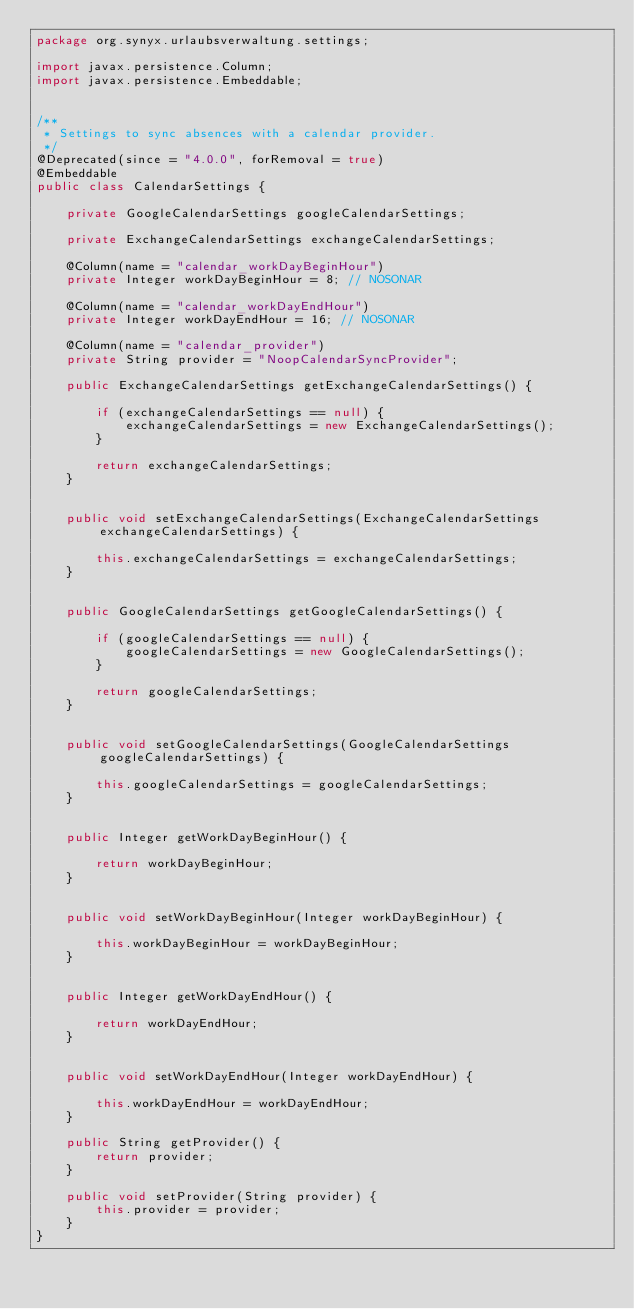Convert code to text. <code><loc_0><loc_0><loc_500><loc_500><_Java_>package org.synyx.urlaubsverwaltung.settings;

import javax.persistence.Column;
import javax.persistence.Embeddable;


/**
 * Settings to sync absences with a calendar provider.
 */
@Deprecated(since = "4.0.0", forRemoval = true)
@Embeddable
public class CalendarSettings {

    private GoogleCalendarSettings googleCalendarSettings;

    private ExchangeCalendarSettings exchangeCalendarSettings;

    @Column(name = "calendar_workDayBeginHour")
    private Integer workDayBeginHour = 8; // NOSONAR

    @Column(name = "calendar_workDayEndHour")
    private Integer workDayEndHour = 16; // NOSONAR

    @Column(name = "calendar_provider")
    private String provider = "NoopCalendarSyncProvider";

    public ExchangeCalendarSettings getExchangeCalendarSettings() {

        if (exchangeCalendarSettings == null) {
            exchangeCalendarSettings = new ExchangeCalendarSettings();
        }

        return exchangeCalendarSettings;
    }


    public void setExchangeCalendarSettings(ExchangeCalendarSettings exchangeCalendarSettings) {

        this.exchangeCalendarSettings = exchangeCalendarSettings;
    }


    public GoogleCalendarSettings getGoogleCalendarSettings() {

        if (googleCalendarSettings == null) {
            googleCalendarSettings = new GoogleCalendarSettings();
        }

        return googleCalendarSettings;
    }


    public void setGoogleCalendarSettings(GoogleCalendarSettings googleCalendarSettings) {

        this.googleCalendarSettings = googleCalendarSettings;
    }


    public Integer getWorkDayBeginHour() {

        return workDayBeginHour;
    }


    public void setWorkDayBeginHour(Integer workDayBeginHour) {

        this.workDayBeginHour = workDayBeginHour;
    }


    public Integer getWorkDayEndHour() {

        return workDayEndHour;
    }


    public void setWorkDayEndHour(Integer workDayEndHour) {

        this.workDayEndHour = workDayEndHour;
    }

    public String getProvider() {
        return provider;
    }

    public void setProvider(String provider) {
        this.provider = provider;
    }
}
</code> 